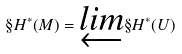Convert formula to latex. <formula><loc_0><loc_0><loc_500><loc_500>\S H ^ { * } ( M ) = \underleftarrow { l i m } \S H ^ { * } ( U )</formula> 